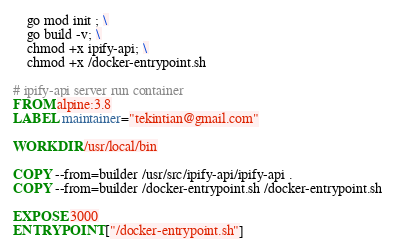<code> <loc_0><loc_0><loc_500><loc_500><_Dockerfile_>    go mod init ; \
    go build -v; \
    chmod +x ipify-api; \
    chmod +x /docker-entrypoint.sh

# ipify-api server run container
FROM alpine:3.8
LABEL maintainer="tekintian@gmail.com"

WORKDIR /usr/local/bin

COPY --from=builder /usr/src/ipify-api/ipify-api .
COPY --from=builder /docker-entrypoint.sh /docker-entrypoint.sh

EXPOSE 3000
ENTRYPOINT ["/docker-entrypoint.sh"]
</code> 